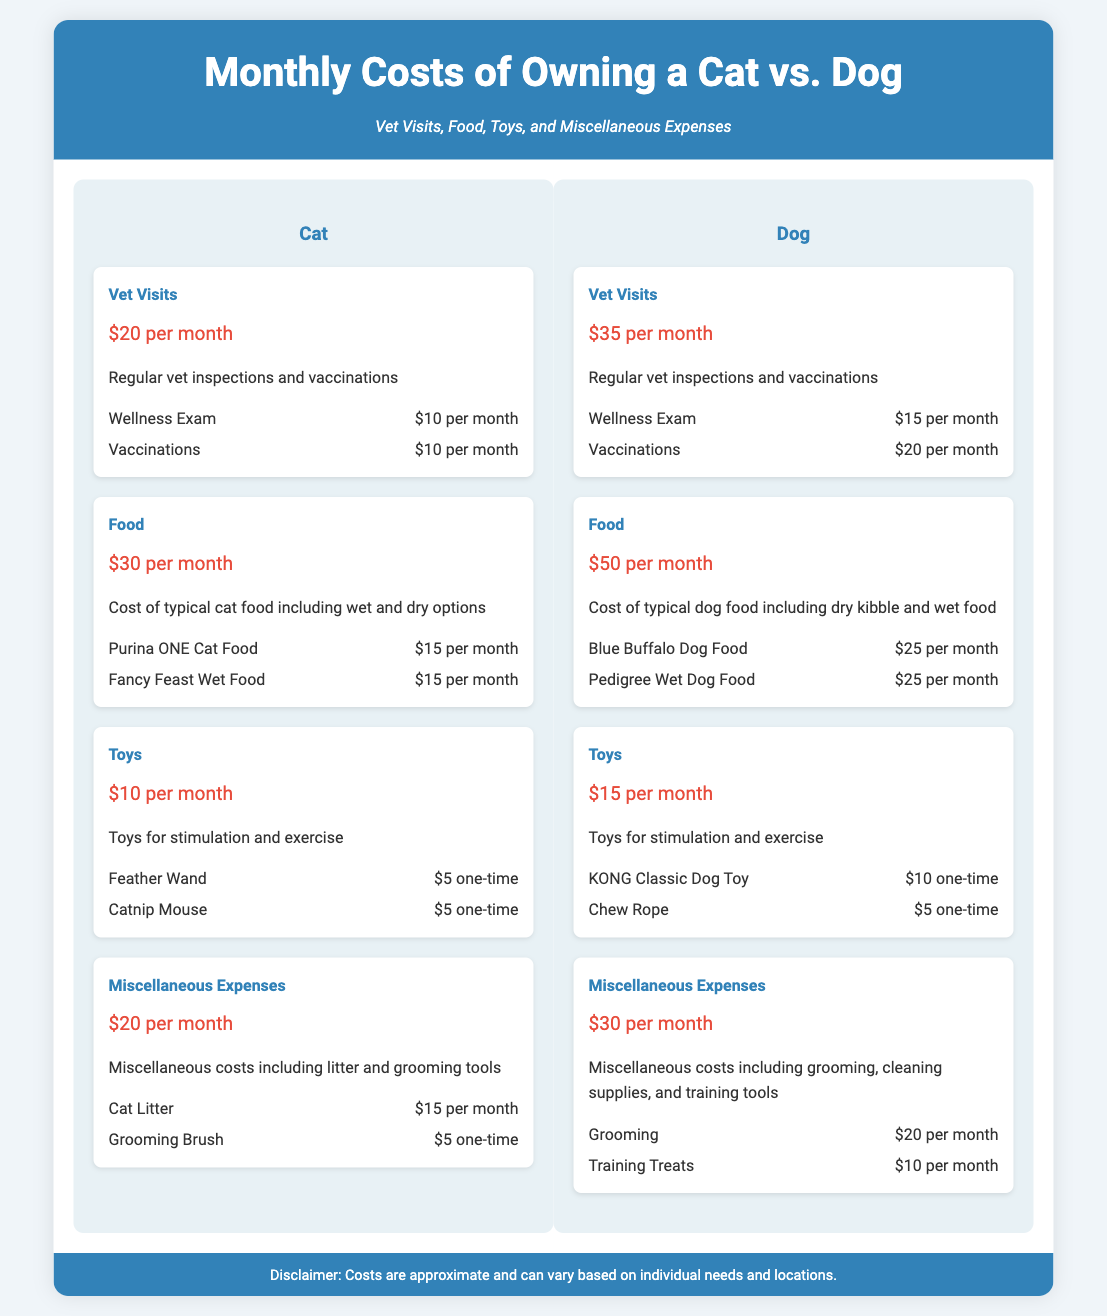What is the monthly cost for vet visits for a cat? The monthly cost for cat vet visits is provided, which is $20 per month.
Answer: $20 per month What is the total monthly cost for dog food? The document specifies that the monthly cost for dog food is $50 per month.
Answer: $50 per month How much do toys cost for a cat per month? The document states that the monthly cost for cat toys is $10 per month.
Answer: $10 per month Which pet has a higher monthly cost for vet visits? The comparison reveals that dogs have a higher monthly cost for vet visits at $35 compared to cats at $20.
Answer: Dogs What is the total monthly cost for miscellaneous expenses for both pets? The total for cats is $20 per month and for dogs is $30 per month, therefore the total is $50 per month.
Answer: $50 per month Which specific item contributes $15 to the cat's monthly costs? The document identifies cat litter as a specific item costing $15 towards the miscellaneous expenses for cats.
Answer: Cat Litter What is the combined monthly cost for cat food? The combined cost for cat food is given as $30 per month.
Answer: $30 per month Which pet has a higher initial toy cost? The initial costs of toys for cats include one-time purchases of $5 each for Feather Wand and Catnip Mouse, while dogs' toys include $10 for KONG Classic and $5 for Chew Rope, leading to higher half for dogs.
Answer: Dogs What is the monthly expense on grooming for dogs? The grooming expense for dogs is mentioned as $20 per month under miscellaneous expenses.
Answer: $20 per month 